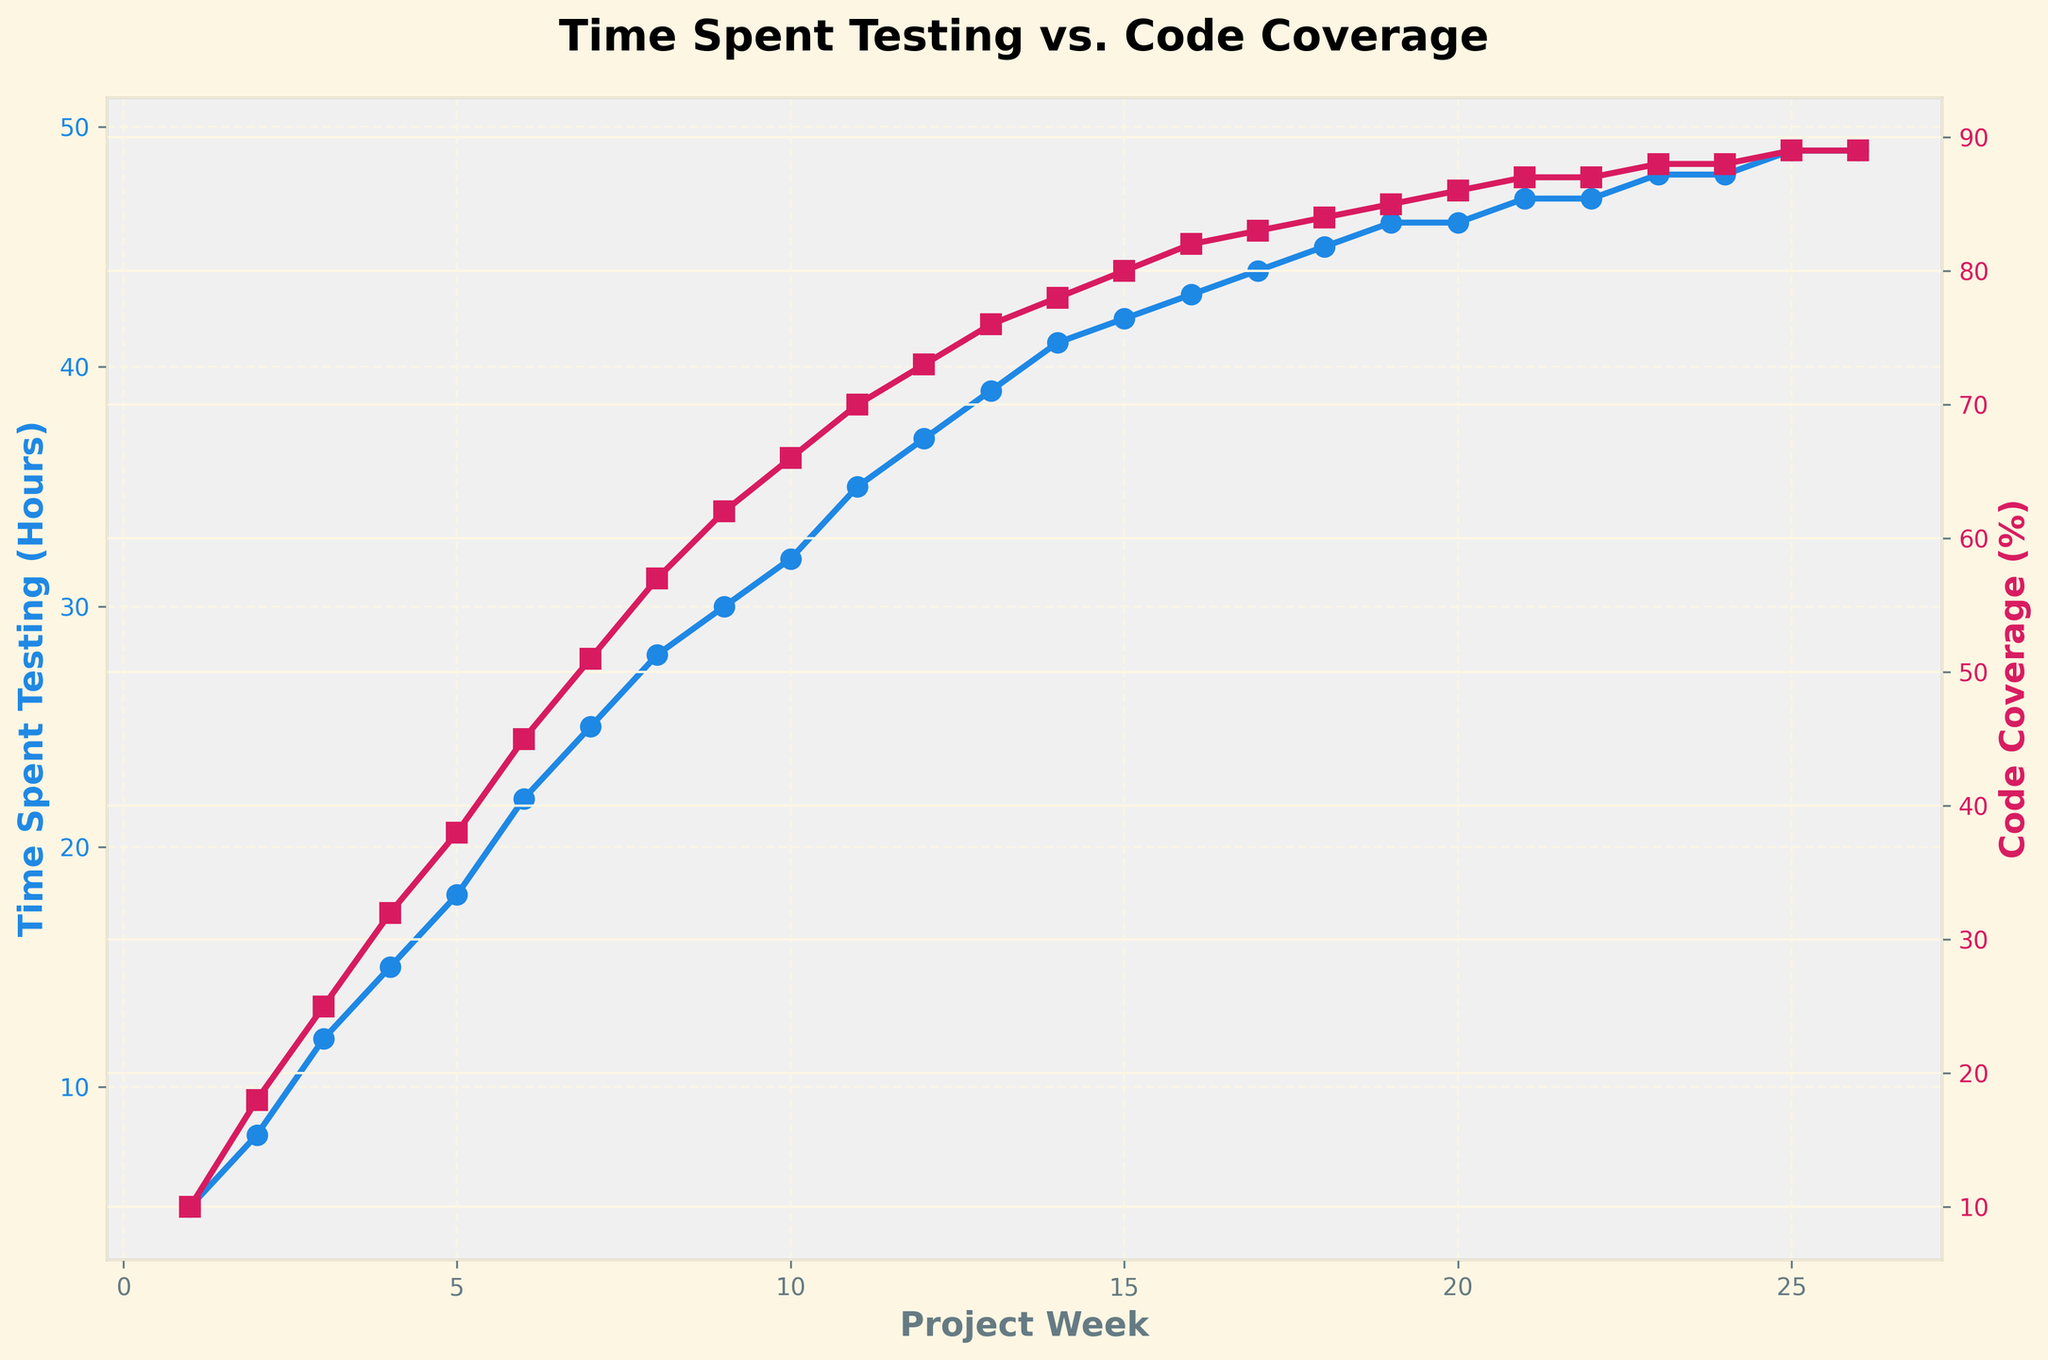How does the code coverage percentage change from Week 1 to Week 12? The coverage percentage at Week 1 is 10% and increases to 73% by Week 12. To find the change, subtract the Week 1 value from the Week 12 value: 73% - 10% = 63%.
Answer: 63% At which week does the time spent on unit testing reach 30 hours? By looking at the plot for 'Time Spent Testing (Hours)', it crosses the 30-hour mark at Week 9.
Answer: Week 9 Compare the increase in time spent on testing between Week 5 and Week 10. At Week 5, the time spent is 18 hours and at Week 10, it is 32 hours. The increase is 32 - 18 = 14 hours.
Answer: 14 hours What is the rate of increase in code coverage percentage from Week 10 to Week 20? Calculate the change in coverage percentage from Week 10 to Week 20: 86% - 66% = 20%. Next, divide by the number of weeks (20 - 10 = 10 weeks): 20% / 10 = 2% per week.
Answer: 2% per week What are the final values for both time spent testing and code coverage percentage at Week 26? At Week 26, trace the plot lines to find: Time Spent Testing is 49 hours and Code Coverage is 89%.
Answer: 49 hours, 89% How much time was spent on unit testing at the halfway point of the project lifecycle, Week 13? Trace the 'Time Spent Testing (Hours)' line at Week 13, which shows 39 hours.
Answer: 39 hours Is there any week where the increase in code coverage percentage halts? From Week 21 to Week 22 and from Week 24 to Week 26, the code coverage percentage remains the same at 87% and 88%, respectively.
Answer: Weeks 21-22 and 24-26 Compare the code coverage percentage achieved in Week 1 to Week 10. Which week shows higher coverage and by how much? At Week 1, the coverage is 10%, and at Week 10, it is 66%. Therefore, Week 10 is higher by 66% - 10% = 56%.
Answer: Week 10, 56% What is the average amount of time spent on testing from Week 1 to Week 5? Sum the time spent from Week 1 to Week 5: 5 + 8 + 12 + 15 + 18 = 58 hours. Average = 58 hours / 5 weeks = 11.6 hours.
Answer: 11.6 hours 